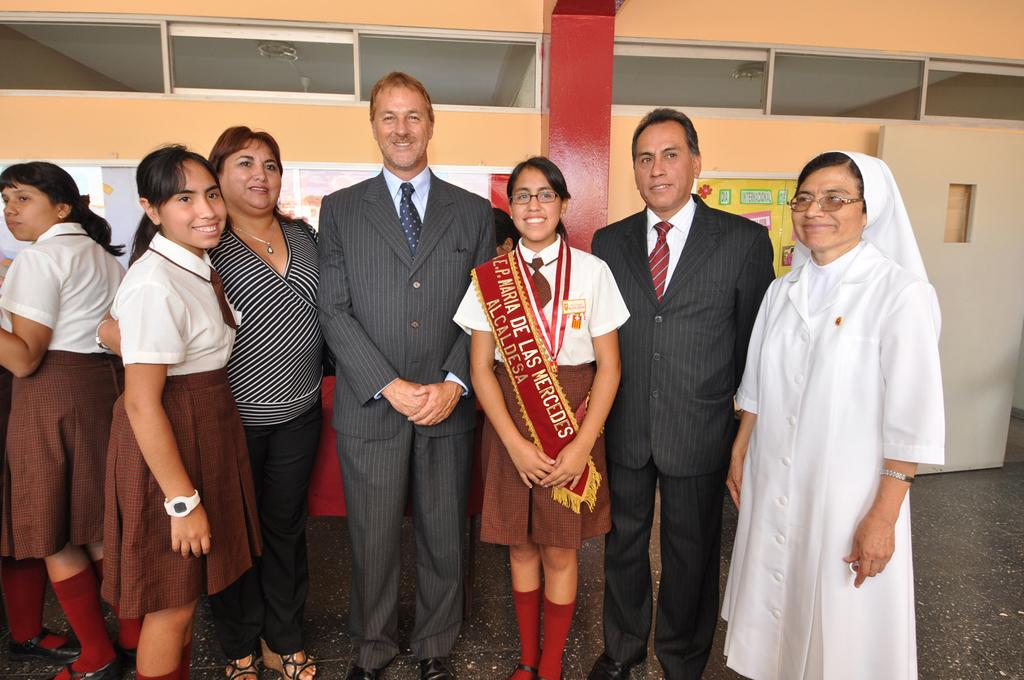How many people are in the image? There is a group of people in the image. What are the people in the image doing? The people are standing and taking a picture. What can be seen in the background of the image? There are cabins in the background of the image. What is attached to the cabins? Papers are stuck on the cabins. Can you tell me how many geese are visible in the image? There are no geese present in the image. What type of debt is being discussed by the people in the image? There is no indication of any debt being discussed in the image; the people are simply taking a picture. 